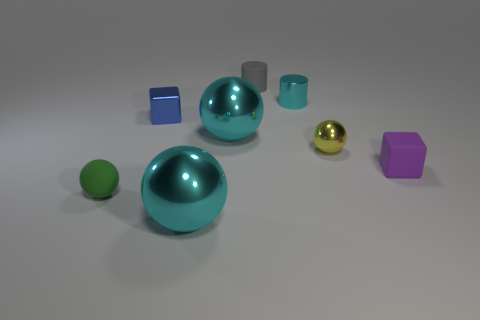Add 1 cyan shiny cylinders. How many objects exist? 9 Subtract all cylinders. How many objects are left? 6 Subtract all tiny blue balls. Subtract all matte balls. How many objects are left? 7 Add 7 cyan metal objects. How many cyan metal objects are left? 10 Add 2 purple matte things. How many purple matte things exist? 3 Subtract 1 blue cubes. How many objects are left? 7 